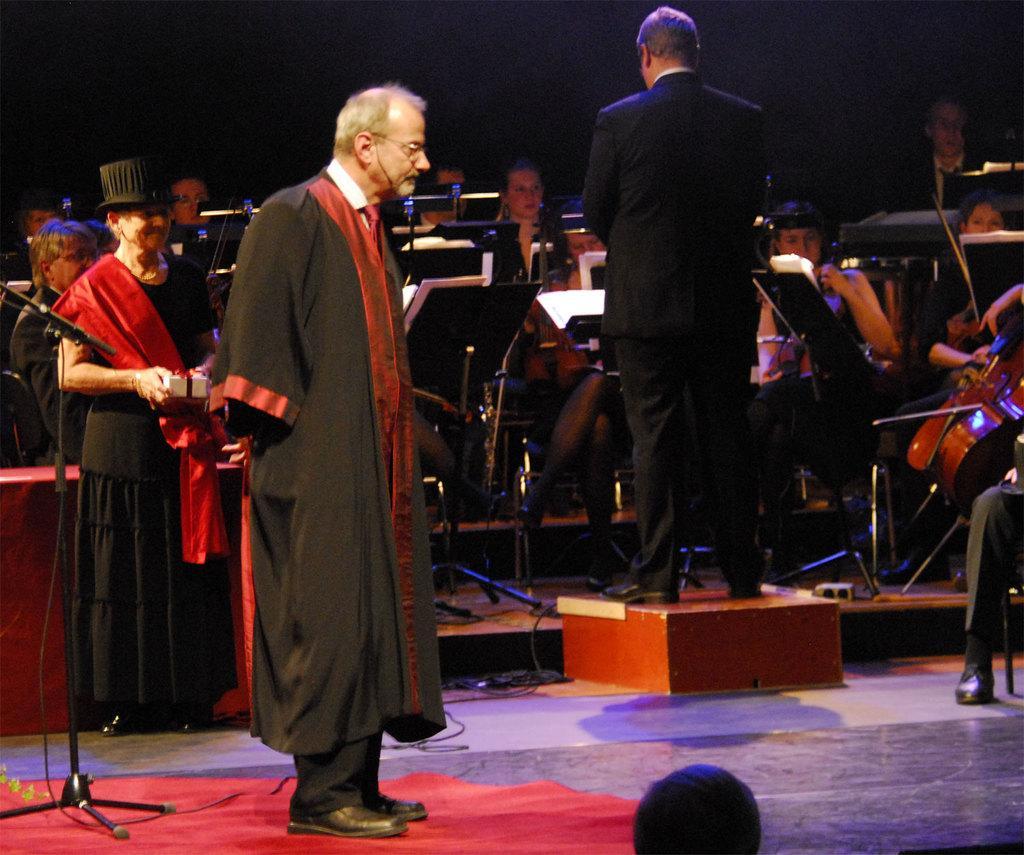Can you describe this image briefly? At the bottom of the image there is cloth. On the left side of the image there is a stand with mic. It is on the cloth. And also there is a man with spectacles and he is standing on the cloth. And there is a man standing on an object. In front of him there are few people sitting and playing musical instruments. And also there are music note stands in front of them. In the image there is a lady with a hat on her head and she is standing. And there is a dark background.  